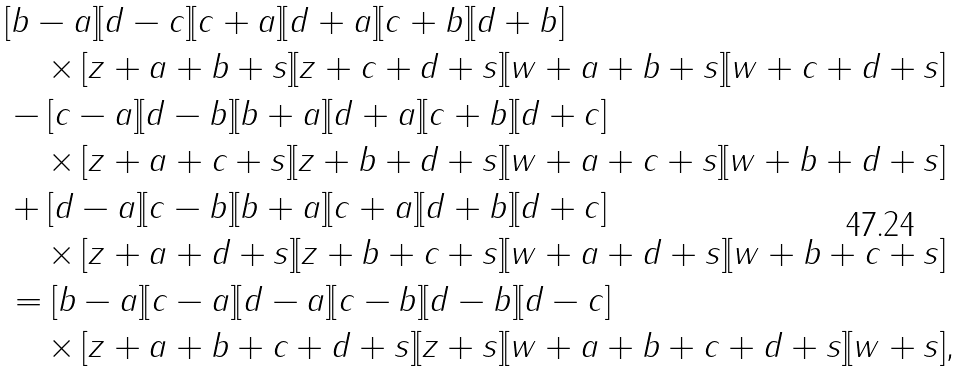<formula> <loc_0><loc_0><loc_500><loc_500>& [ b - a ] [ d - c ] [ c + a ] [ d + a ] [ c + b ] [ d + b ] \\ & \quad \times [ z + a + b + s ] [ z + c + d + s ] [ w + a + b + s ] [ w + c + d + s ] \\ & - [ c - a ] [ d - b ] [ b + a ] [ d + a ] [ c + b ] [ d + c ] \\ & \quad \times [ z + a + c + s ] [ z + b + d + s ] [ w + a + c + s ] [ w + b + d + s ] \\ & + [ d - a ] [ c - b ] [ b + a ] [ c + a ] [ d + b ] [ d + c ] \\ & \quad \times [ z + a + d + s ] [ z + b + c + s ] [ w + a + d + s ] [ w + b + c + s ] \\ & = [ b - a ] [ c - a ] [ d - a ] [ c - b ] [ d - b ] [ d - c ] \\ & \quad \times [ z + a + b + c + d + s ] [ z + s ] [ w + a + b + c + d + s ] [ w + s ] ,</formula> 